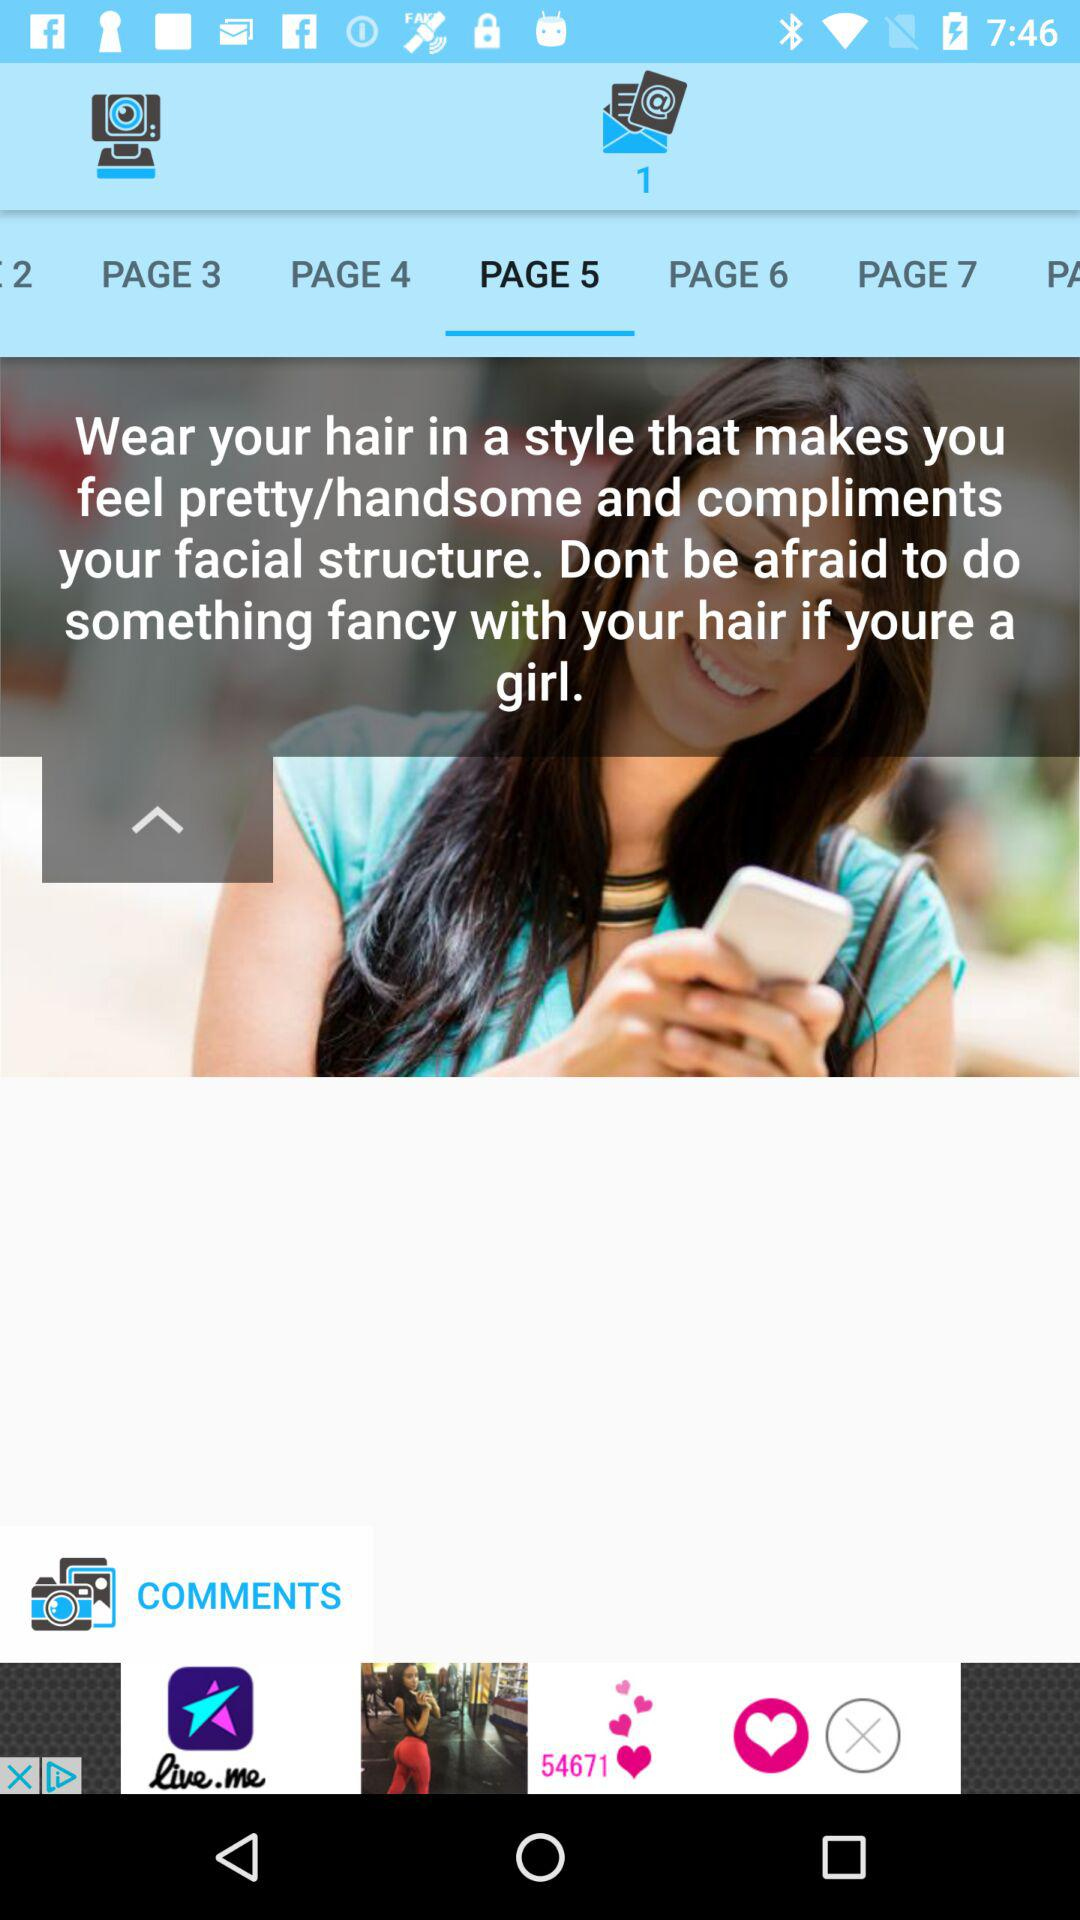How many unread messages are there? There is 1 unread message. 